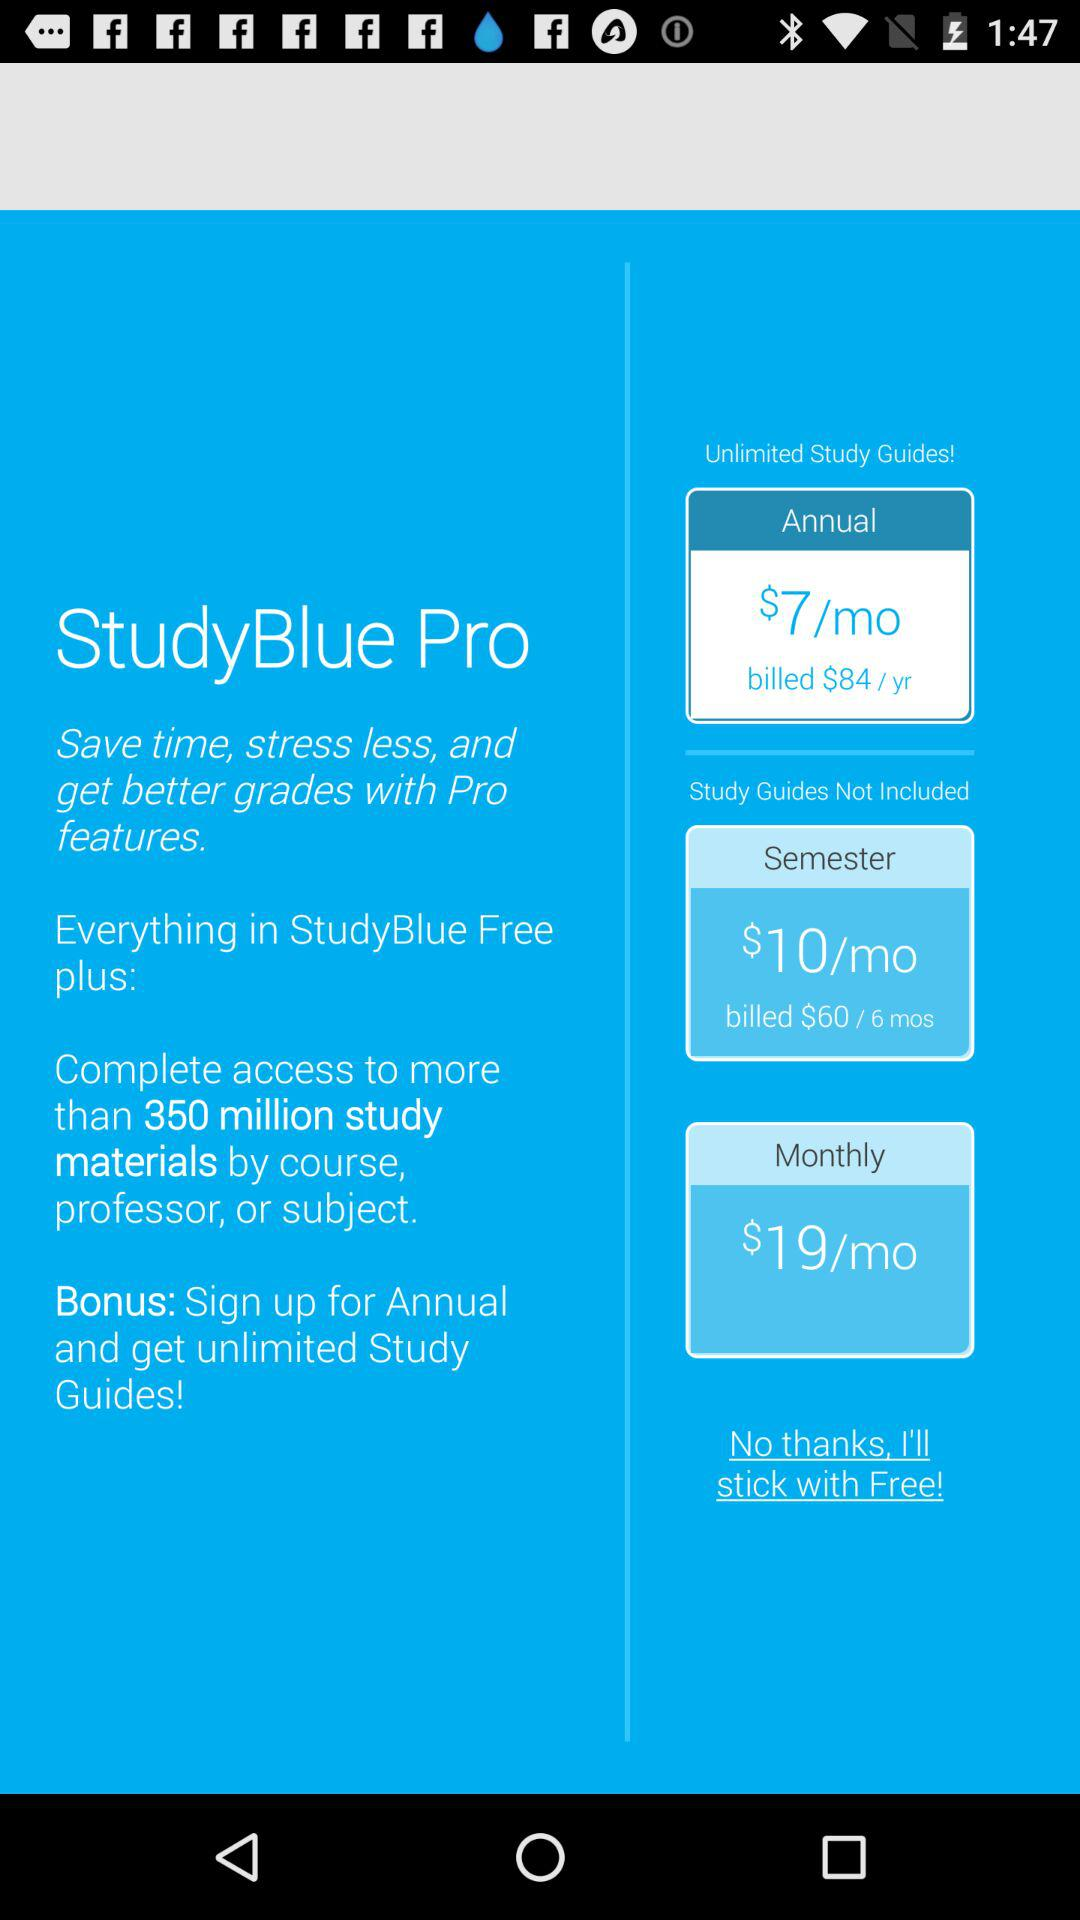In which option are the study guides provided? The study guides are provided in the "Annual" option. 